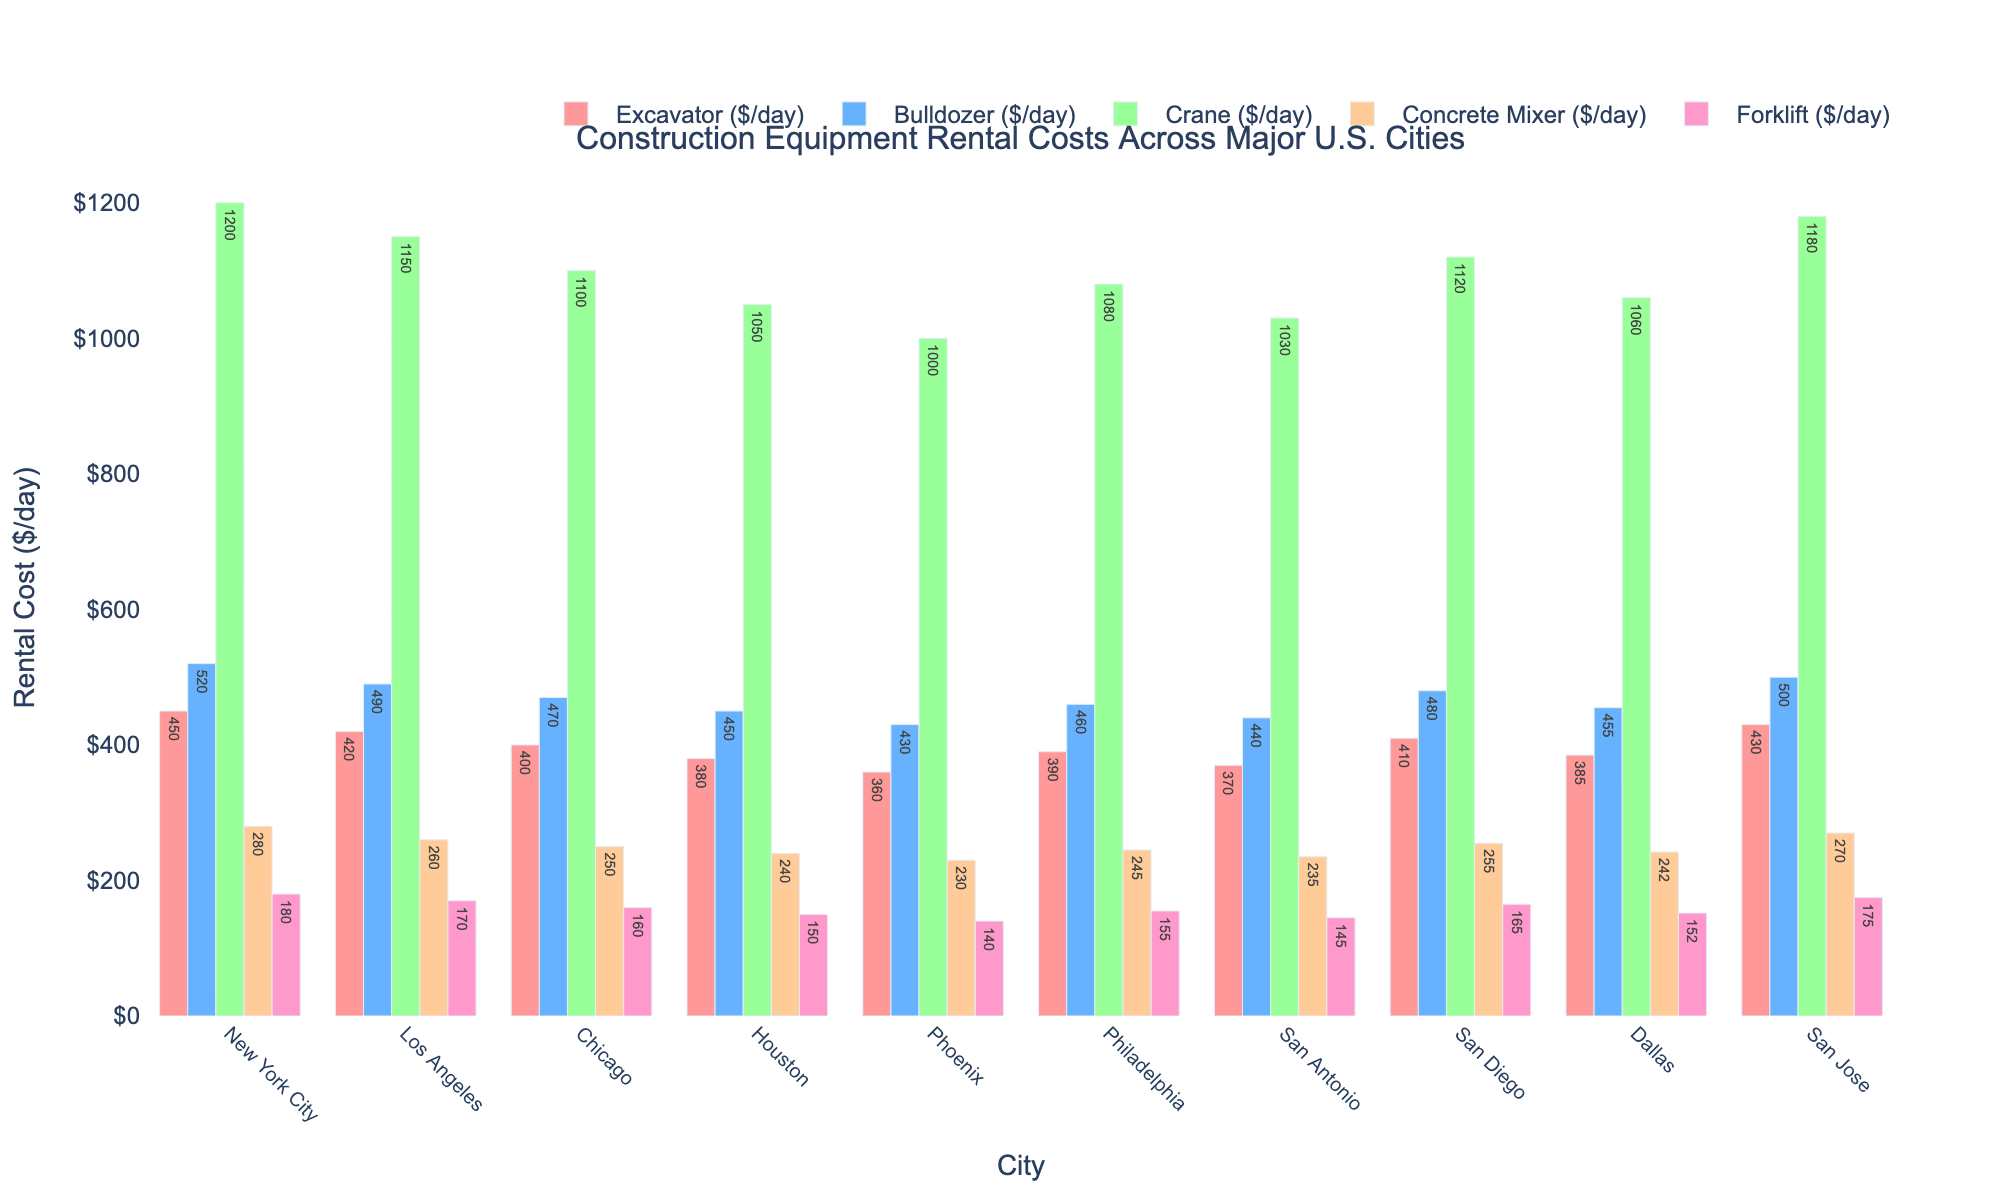What's the rental cost of an excavator in San Diego? Look for San Diego on the x-axis and find the corresponding bar for "Excavator" in the grouping. The bar height and text label indicate the rental cost.
Answer: 410 Which city has the highest rental cost for a crane? Compare the heights and text labels of the "Crane" bars across all cities. The tallest bar with the highest label is for New York City.
Answer: New York City What is the average rental cost of a concrete mixer across all cities? Sum the rental costs of concrete mixers in all cities and divide by the number of cities: (280 + 260 + 250 + 240 + 230 + 245 + 235 + 255 + 242 + 270) / 10.
Answer: 250.7 Is the rental cost of a forklift higher in Philadelphia or Dallas? Compare the heights and text labels of the "Forklift" bars for Philadelphia and Dallas. Philadelphia shows 155 and Dallas shows 152.
Answer: Philadelphia What is the difference in the rental costs of bulldozers between Los Angeles and Houston? Find the rental costs of bulldozers in Los Angeles (490) and Houston (450), then subtract the smaller amount from the larger: 490 - 450.
Answer: 40 What is the total rental cost of an excavator and a crane in New York City? Add the rental costs of an excavator (450) and a crane (1200) in New York City: 450 + 1200.
Answer: 1650 Which city has the lowest rental cost for a concrete mixer? Compare the heights and text labels of the "Concrete Mixer" bars across all cities. The shortest bar with the lowest label is for Phoenix.
Answer: Phoenix What is the sum of rental costs of all equipment types in Chicago? Sum the rental costs of all five equipment types in Chicago: 400 + 470 + 1100 + 250 + 160.
Answer: 2380 Is there any city where the rental cost of every equipment type is below $500/day? Check each equipment type's rental costs for all cities. Houston, Phoenix, San Antonio, and Dallas have all rental costs below $500/day.
Answer: Yes What is the ranking of cities by the rental cost of a bulldozer, from highest to lowest? Order the cities by the heights and text labels of the "Bulldozer" bars, starting from the highest (New York City) to the lowest (Phoenix). New York City > Los Angeles > San Jose > San Diego > Chicago > Philadelphia > Dallas > San Antonio > Houston > Phoenix
Answer: New York City, Los Angeles, San Jose, San Diego, Chicago, Philadelphia, Dallas, San Antonio, Houston, Phoenix 